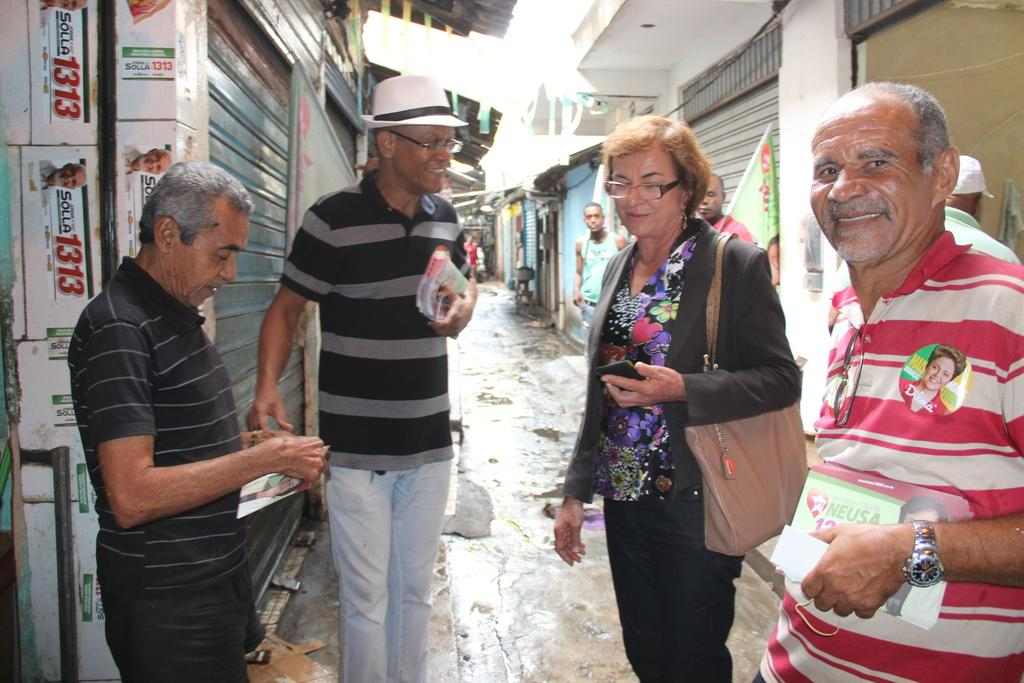Who or what is present in the image? There are people in the image. What are the people holding in their hands? The people are holding papers. What can be seen on both sides of the image? There are shops on both the right and left sides of the image. Can you see a rabbit playing with a balloon in the image? No, there is no rabbit or balloon present in the image. 